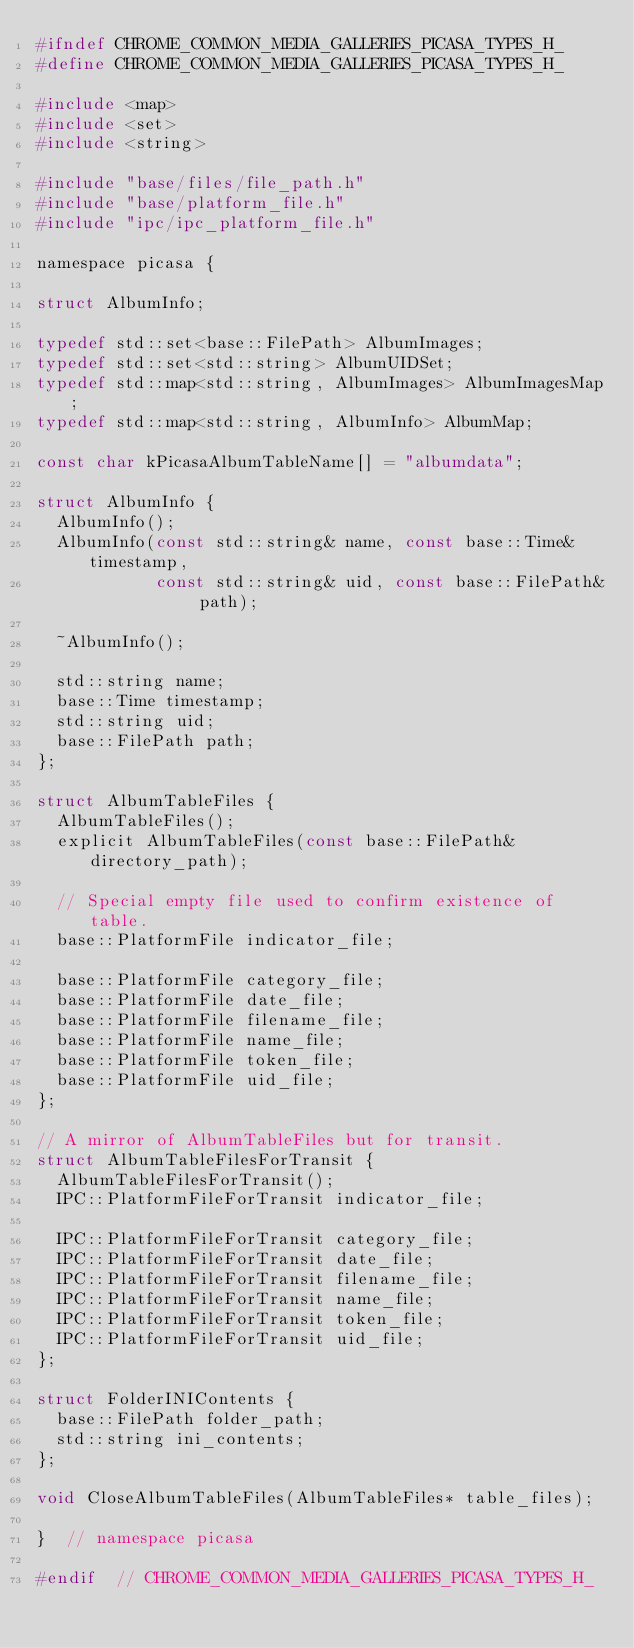<code> <loc_0><loc_0><loc_500><loc_500><_C_>#ifndef CHROME_COMMON_MEDIA_GALLERIES_PICASA_TYPES_H_
#define CHROME_COMMON_MEDIA_GALLERIES_PICASA_TYPES_H_

#include <map>
#include <set>
#include <string>

#include "base/files/file_path.h"
#include "base/platform_file.h"
#include "ipc/ipc_platform_file.h"

namespace picasa {

struct AlbumInfo;

typedef std::set<base::FilePath> AlbumImages;
typedef std::set<std::string> AlbumUIDSet;
typedef std::map<std::string, AlbumImages> AlbumImagesMap;
typedef std::map<std::string, AlbumInfo> AlbumMap;

const char kPicasaAlbumTableName[] = "albumdata";

struct AlbumInfo {
  AlbumInfo();
  AlbumInfo(const std::string& name, const base::Time& timestamp,
            const std::string& uid, const base::FilePath& path);

  ~AlbumInfo();

  std::string name;
  base::Time timestamp;
  std::string uid;
  base::FilePath path;
};

struct AlbumTableFiles {
  AlbumTableFiles();
  explicit AlbumTableFiles(const base::FilePath& directory_path);

  // Special empty file used to confirm existence of table.
  base::PlatformFile indicator_file;

  base::PlatformFile category_file;
  base::PlatformFile date_file;
  base::PlatformFile filename_file;
  base::PlatformFile name_file;
  base::PlatformFile token_file;
  base::PlatformFile uid_file;
};

// A mirror of AlbumTableFiles but for transit.
struct AlbumTableFilesForTransit {
  AlbumTableFilesForTransit();
  IPC::PlatformFileForTransit indicator_file;

  IPC::PlatformFileForTransit category_file;
  IPC::PlatformFileForTransit date_file;
  IPC::PlatformFileForTransit filename_file;
  IPC::PlatformFileForTransit name_file;
  IPC::PlatformFileForTransit token_file;
  IPC::PlatformFileForTransit uid_file;
};

struct FolderINIContents {
  base::FilePath folder_path;
  std::string ini_contents;
};

void CloseAlbumTableFiles(AlbumTableFiles* table_files);

}  // namespace picasa

#endif  // CHROME_COMMON_MEDIA_GALLERIES_PICASA_TYPES_H_
</code> 